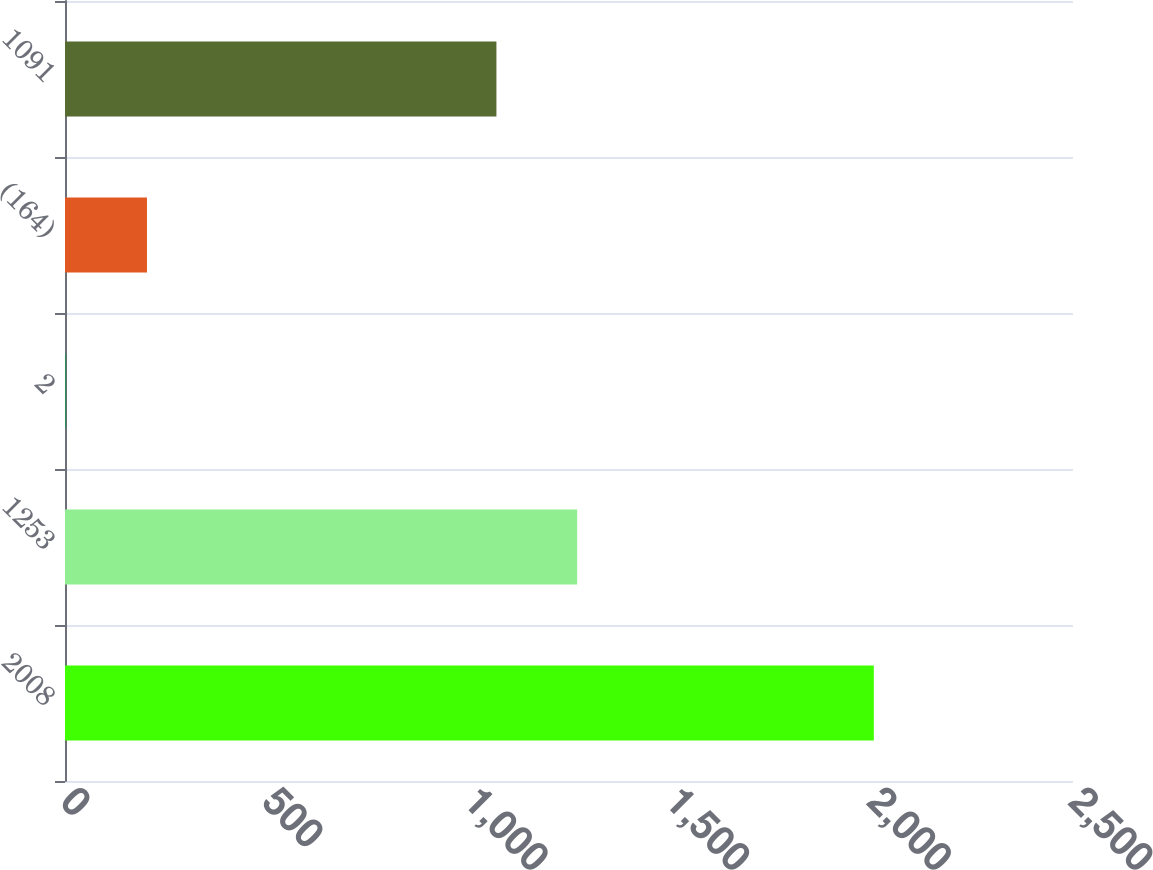<chart> <loc_0><loc_0><loc_500><loc_500><bar_chart><fcel>2008<fcel>1253<fcel>2<fcel>(164)<fcel>1091<nl><fcel>2006<fcel>1270.3<fcel>3<fcel>203.3<fcel>1070<nl></chart> 